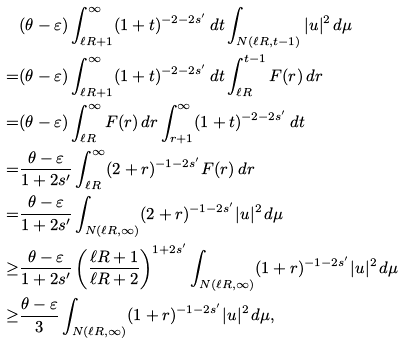<formula> <loc_0><loc_0><loc_500><loc_500>& ( \theta - \varepsilon ) \int _ { \ell R + 1 } ^ { \infty } ( 1 + t ) ^ { - 2 - 2 s ^ { \prime } } \, d t \int _ { N ( \ell R , t - 1 ) } | u | ^ { 2 } \, d \mu \\ = & ( \theta - \varepsilon ) \int _ { \ell R + 1 } ^ { \infty } ( 1 + t ) ^ { - 2 - 2 s ^ { \prime } } \, d t \int _ { \ell R } ^ { t - 1 } F ( r ) \, d r \\ = & ( \theta - \varepsilon ) \int _ { \ell R } ^ { \infty } F ( r ) \, d r \int _ { r + 1 } ^ { \infty } ( 1 + t ) ^ { - 2 - 2 s ^ { \prime } } \, d t \\ = & \frac { \theta - \varepsilon } { 1 + 2 s ^ { \prime } } \int _ { \ell R } ^ { \infty } ( 2 + r ) ^ { - 1 - 2 s ^ { \prime } } F ( r ) \, d r \\ = & \frac { \theta - \varepsilon } { 1 + 2 s ^ { \prime } } \int _ { N ( \ell R , \infty ) } ( 2 + r ) ^ { - 1 - 2 s ^ { \prime } } | u | ^ { 2 } \, d \mu \\ \geq & \frac { \theta - \varepsilon } { 1 + 2 s ^ { \prime } } \left ( \frac { \ell R + 1 } { \ell R + 2 } \right ) ^ { 1 + 2 s ^ { \prime } } \int _ { N ( \ell R , \infty ) } ( 1 + r ) ^ { - 1 - 2 s ^ { \prime } } | u | ^ { 2 } \, d \mu \\ \geq & \frac { \theta - \varepsilon } { 3 } \int _ { N ( \ell R , \infty ) } ( 1 + r ) ^ { - 1 - 2 s ^ { \prime } } | u | ^ { 2 } \, d \mu ,</formula> 